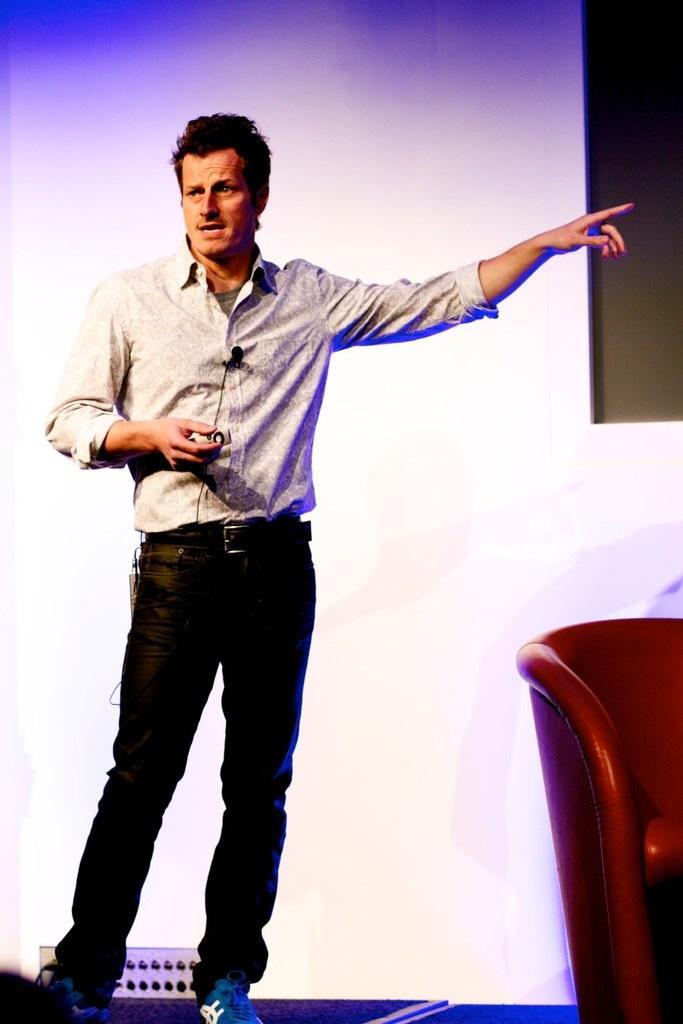How would you summarize this image in a sentence or two? In this picture the man is standing and talking something and pointing his finger, behind him there is a chair, in the background we can see a screen. 